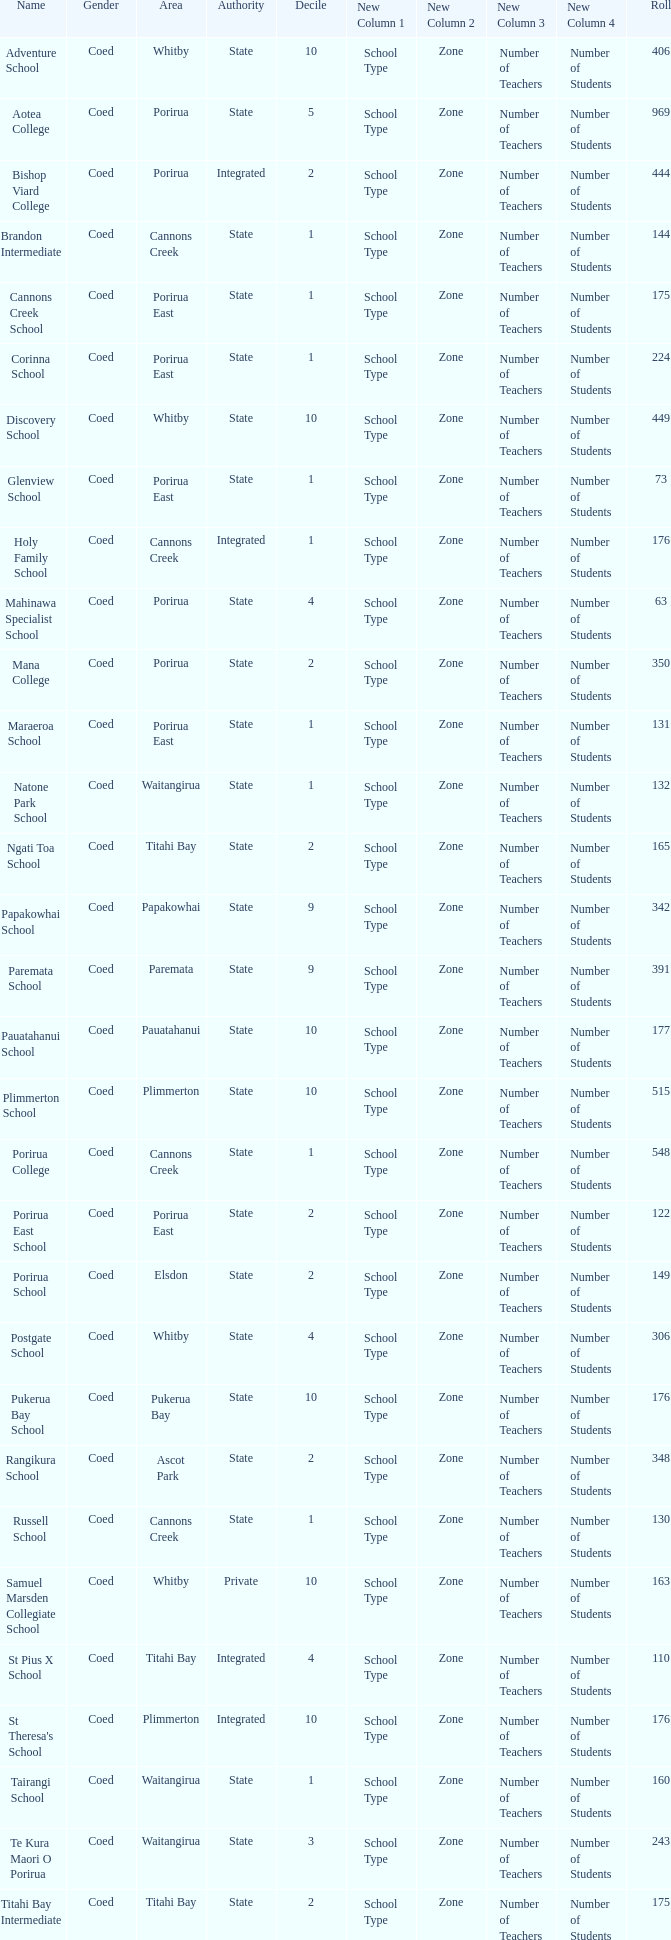What was the decile of samuel marsden collegiate school in whitby, when it had a student body larger than 163? 0.0. 